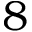Convert formula to latex. <formula><loc_0><loc_0><loc_500><loc_500>8</formula> 